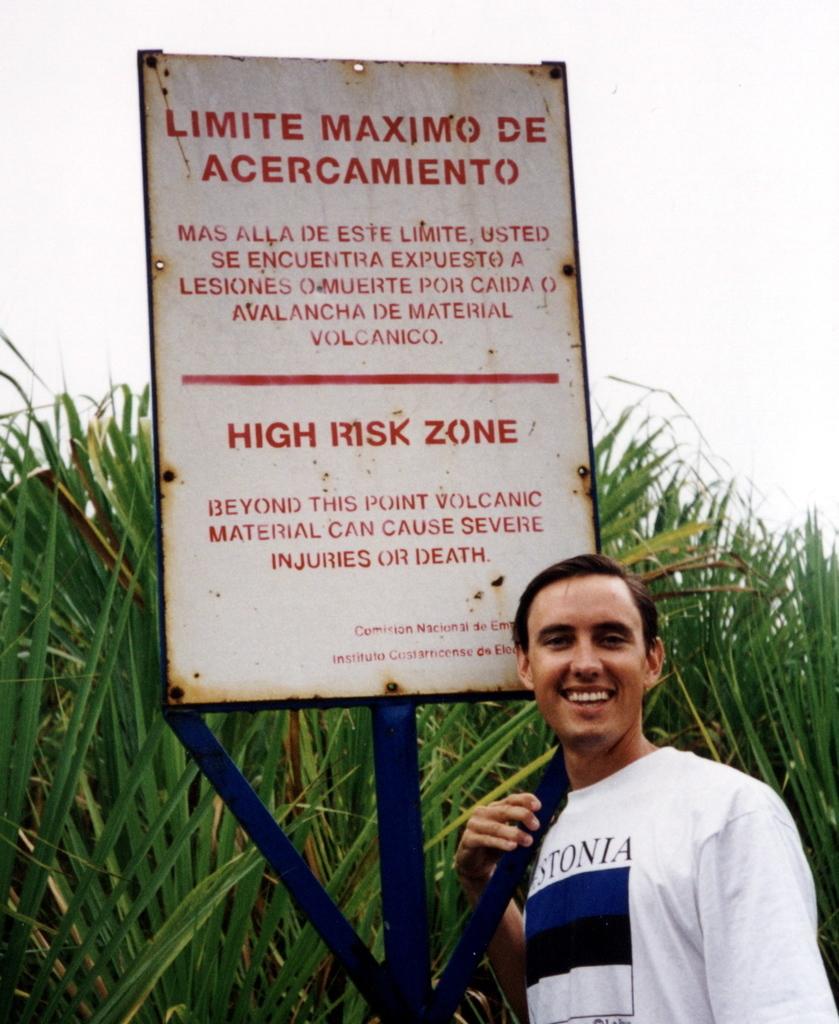What type of zone is this?
Provide a short and direct response. High risk. What kind of material causes the risk?
Offer a very short reply. Volcanic. 